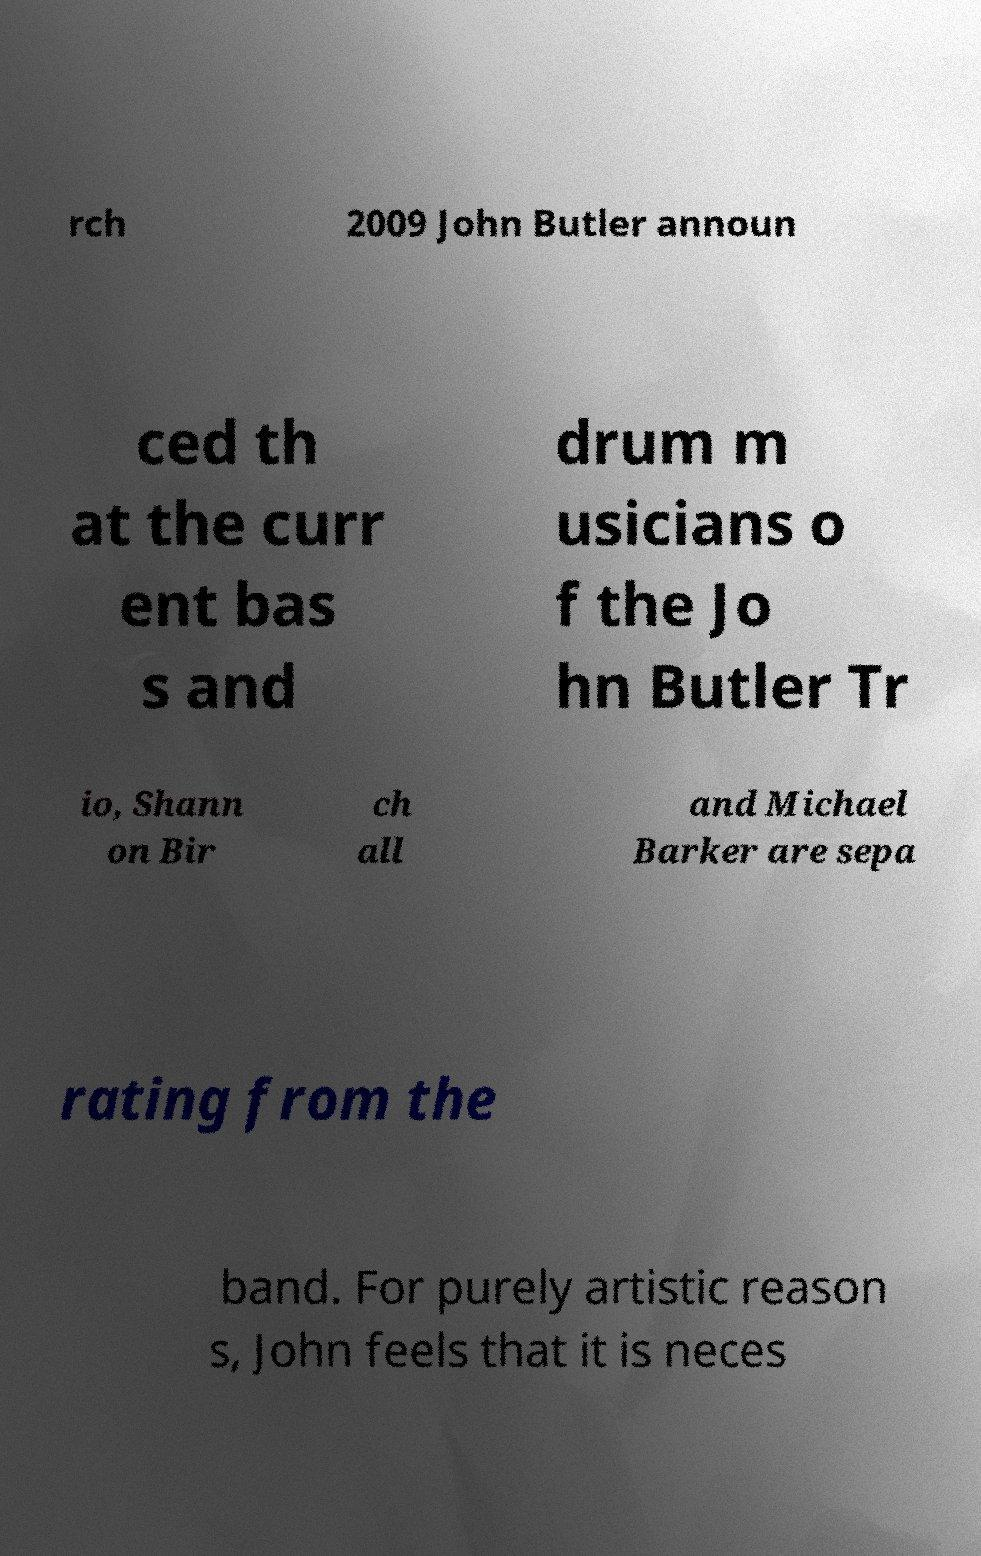Can you accurately transcribe the text from the provided image for me? rch 2009 John Butler announ ced th at the curr ent bas s and drum m usicians o f the Jo hn Butler Tr io, Shann on Bir ch all and Michael Barker are sepa rating from the band. For purely artistic reason s, John feels that it is neces 